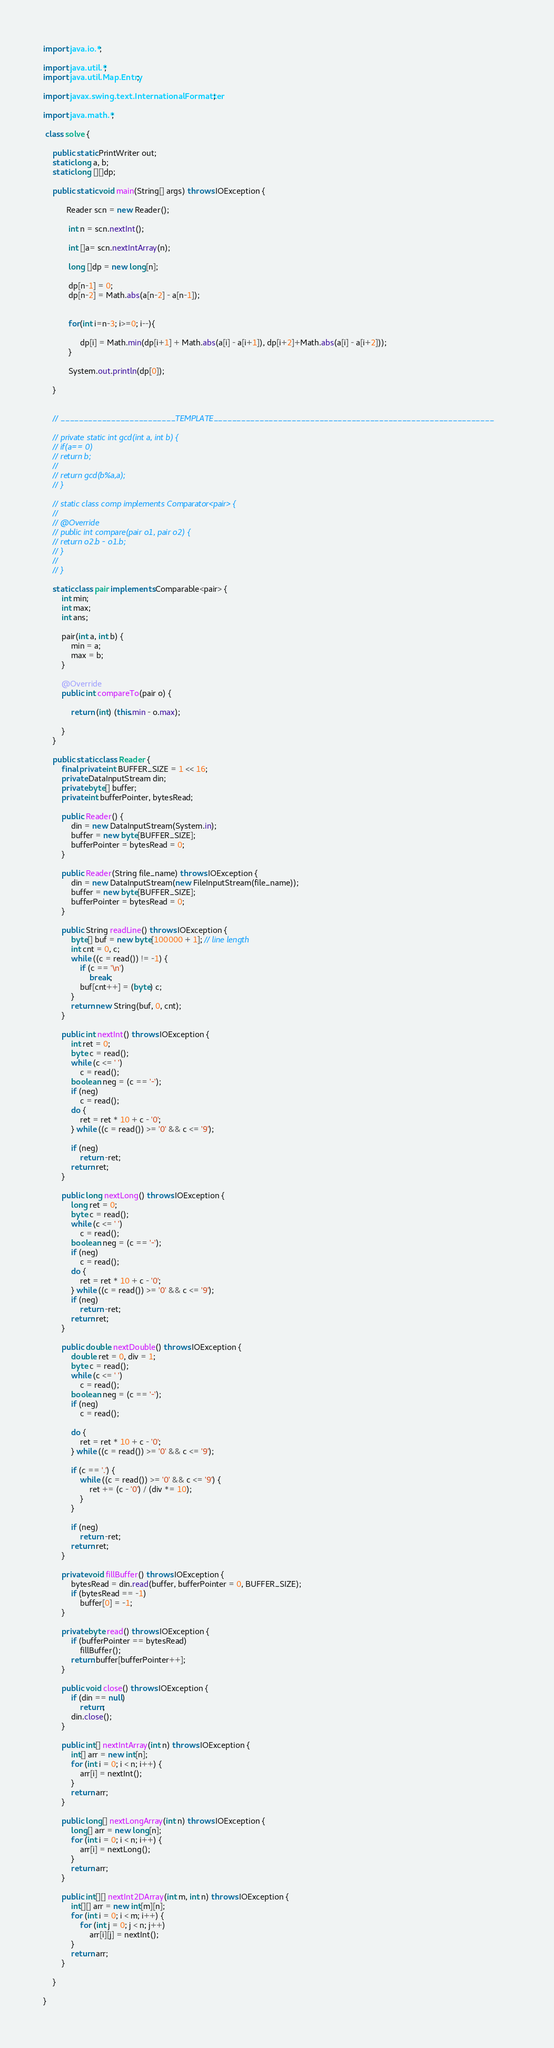<code> <loc_0><loc_0><loc_500><loc_500><_Java_>
import java.io.*;

import java.util.*;
import java.util.Map.Entry;

import javax.swing.text.InternationalFormatter;

import java.math.*;

 class solve {

	public static PrintWriter out;
	static long a, b;
	static long [][]dp;

	public static void main(String[] args) throws IOException {
		
		  Reader scn = new Reader();
		  
		   int n = scn.nextInt();
		   
		   int []a= scn.nextIntArray(n);
		   
		   long []dp = new long[n];
		   
		   dp[n-1] = 0;
		   dp[n-2] = Math.abs(a[n-2] - a[n-1]);
		   
		   
		   for(int i=n-3; i>=0; i--){
			   
			    dp[i] = Math.min(dp[i+1] + Math.abs(a[i] - a[i+1]), dp[i+2]+Math.abs(a[i] - a[i+2]));
		   }
		
		   System.out.println(dp[0]);
		   
	}


	// _________________________TEMPLATE_____________________________________________________________

	// private static int gcd(int a, int b) {
	// if(a== 0)
	// return b;
	//
	// return gcd(b%a,a);
	// }

	// static class comp implements Comparator<pair> {
	//
	// @Override
	// public int compare(pair o1, pair o2) {
	// return o2.b - o1.b;
	// }
	//
	// }

	static class pair implements Comparable<pair> {
		int min;
		int max;
		int ans;

		pair(int a, int b) {
			min = a;
			max = b;
		}

		@Override
		public int compareTo(pair o) {

			return (int) (this.min - o.max);

		}
	}

	public static class Reader {
		final private int BUFFER_SIZE = 1 << 16;
		private DataInputStream din;
		private byte[] buffer;
		private int bufferPointer, bytesRead;

		public Reader() {
			din = new DataInputStream(System.in);
			buffer = new byte[BUFFER_SIZE];
			bufferPointer = bytesRead = 0;
		}

		public Reader(String file_name) throws IOException {
			din = new DataInputStream(new FileInputStream(file_name));
			buffer = new byte[BUFFER_SIZE];
			bufferPointer = bytesRead = 0;
		}

		public String readLine() throws IOException {
			byte[] buf = new byte[100000 + 1]; // line length
			int cnt = 0, c;
			while ((c = read()) != -1) {
				if (c == '\n')
					break;
				buf[cnt++] = (byte) c;
			}
			return new String(buf, 0, cnt);
		}

		public int nextInt() throws IOException {
			int ret = 0;
			byte c = read();
			while (c <= ' ')
				c = read();
			boolean neg = (c == '-');
			if (neg)
				c = read();
			do {
				ret = ret * 10 + c - '0';
			} while ((c = read()) >= '0' && c <= '9');

			if (neg)
				return -ret;
			return ret;
		}

		public long nextLong() throws IOException {
			long ret = 0;
			byte c = read();
			while (c <= ' ')
				c = read();
			boolean neg = (c == '-');
			if (neg)
				c = read();
			do {
				ret = ret * 10 + c - '0';
			} while ((c = read()) >= '0' && c <= '9');
			if (neg)
				return -ret;
			return ret;
		}

		public double nextDouble() throws IOException {
			double ret = 0, div = 1;
			byte c = read();
			while (c <= ' ')
				c = read();
			boolean neg = (c == '-');
			if (neg)
				c = read();

			do {
				ret = ret * 10 + c - '0';
			} while ((c = read()) >= '0' && c <= '9');

			if (c == '.') {
				while ((c = read()) >= '0' && c <= '9') {
					ret += (c - '0') / (div *= 10);
				}
			}

			if (neg)
				return -ret;
			return ret;
		}

		private void fillBuffer() throws IOException {
			bytesRead = din.read(buffer, bufferPointer = 0, BUFFER_SIZE);
			if (bytesRead == -1)
				buffer[0] = -1;
		}

		private byte read() throws IOException {
			if (bufferPointer == bytesRead)
				fillBuffer();
			return buffer[bufferPointer++];
		}

		public void close() throws IOException {
			if (din == null)
				return;
			din.close();
		}

		public int[] nextIntArray(int n) throws IOException {
			int[] arr = new int[n];
			for (int i = 0; i < n; i++) {
				arr[i] = nextInt();
			}
			return arr;
		}

		public long[] nextLongArray(int n) throws IOException {
			long[] arr = new long[n];
			for (int i = 0; i < n; i++) {
				arr[i] = nextLong();
			}
			return arr;
		}

		public int[][] nextInt2DArray(int m, int n) throws IOException {
			int[][] arr = new int[m][n];
			for (int i = 0; i < m; i++) {
				for (int j = 0; j < n; j++)
					arr[i][j] = nextInt();
			}
			return arr;
		}

	}

}</code> 